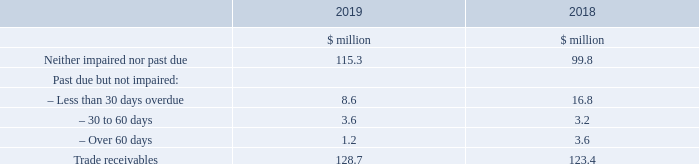30. Financial instruments and financial risk management continued
b) Credit risk continued
The composition of trade receivables at 31 December is as follows:
The Group closely monitors amounts due from customers and performs activities such as credit checks and reviews of payment history and has put in place appropriate credit approval limits. Based on these procedures, management assessed the quality of those receivables that are past due but not impaired as low risk.
The receivables’ provision is based on expected credit losses. The movement on the provision during the year is given in note 20. The value of impaired trade receivables is $1.4 million (2018 $0.9 million). For all other financial assets, the maximum exposure to credit risk is represented by the carrying amount.
What activities does the Group perform when it closely monitors amounts due from customers? Performs activities such as credit checks and reviews of payment history and has put in place appropriate credit approval limits. What is the receivables' provision based on? Expected credit losses. What are the composition of trade receivables which are past due but not impaired? Less than 30 days overdue, 30 to 60 days, over 60 days. In which year was the amount of trade receivables larger? 128.7>123.4
Answer: 2019. What was the change in trade receivables?
Answer scale should be: million. 128.7-123.4
Answer: 5.3. What was the percentage change in trade receivables?
Answer scale should be: percent. (128.7-123.4)/123.4
Answer: 4.29. 